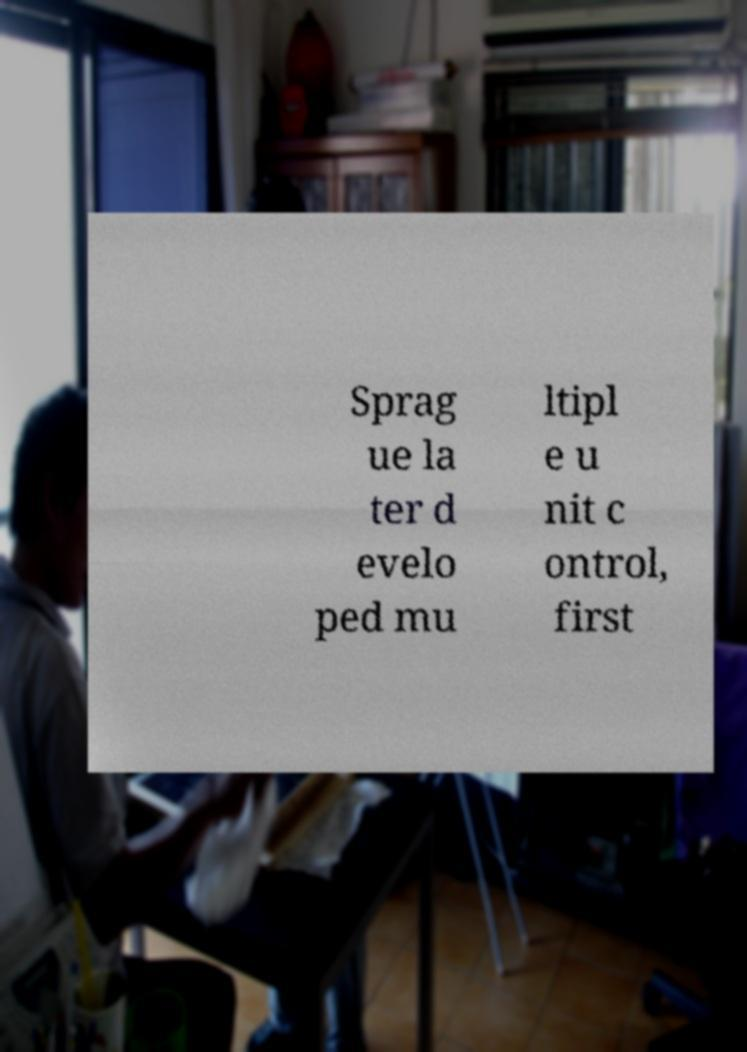Please identify and transcribe the text found in this image. Sprag ue la ter d evelo ped mu ltipl e u nit c ontrol, first 